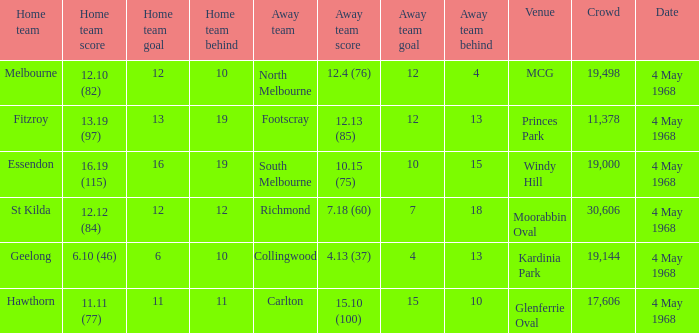What team played at Moorabbin Oval to a crowd of 19,144? St Kilda. 